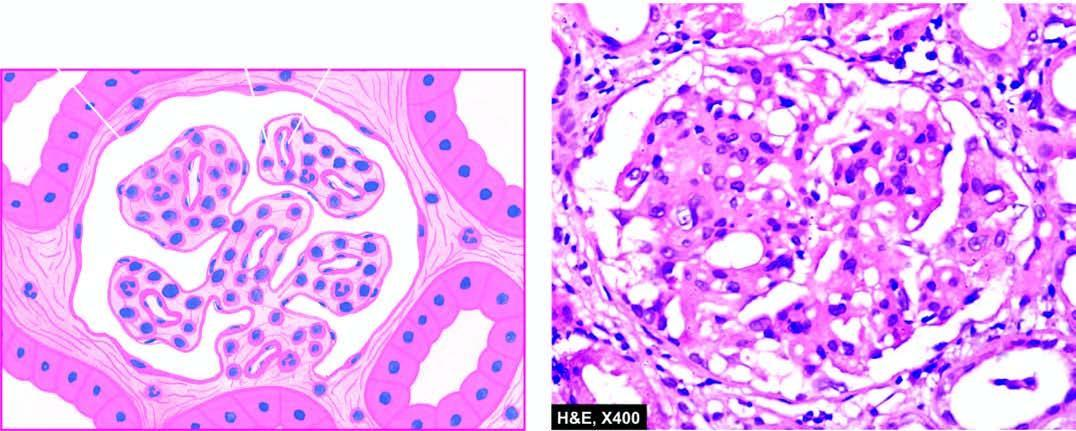s the silicotic nodule widespread thickening of the gbm?
Answer the question using a single word or phrase. No 